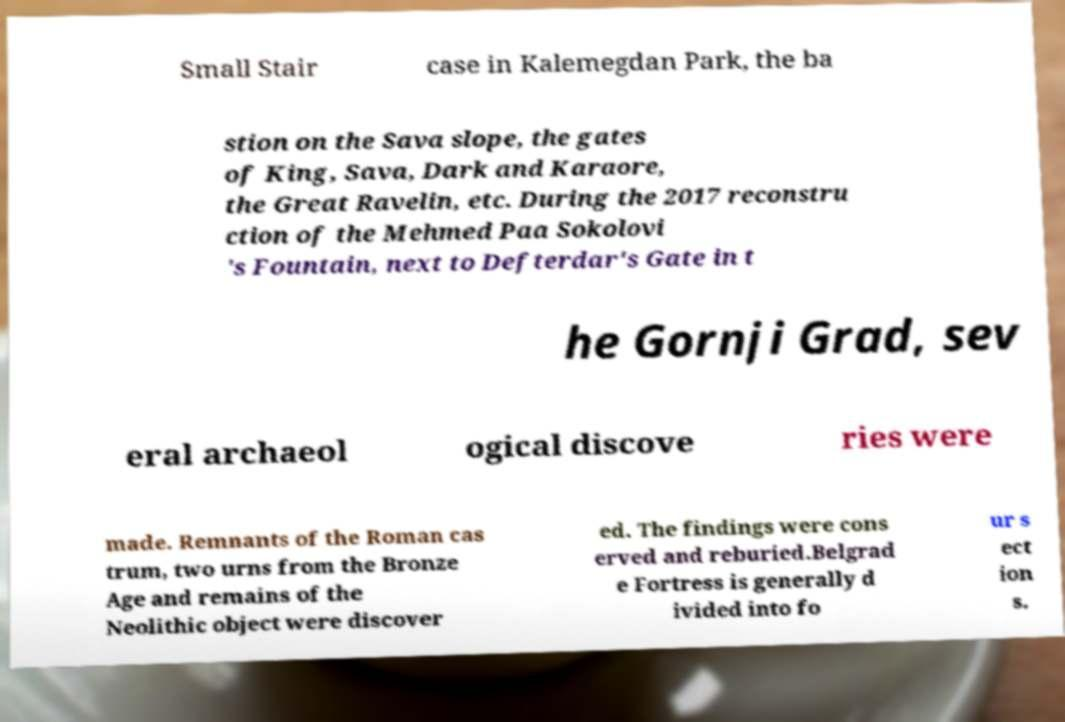Please read and relay the text visible in this image. What does it say? Small Stair case in Kalemegdan Park, the ba stion on the Sava slope, the gates of King, Sava, Dark and Karaore, the Great Ravelin, etc. During the 2017 reconstru ction of the Mehmed Paa Sokolovi 's Fountain, next to Defterdar's Gate in t he Gornji Grad, sev eral archaeol ogical discove ries were made. Remnants of the Roman cas trum, two urns from the Bronze Age and remains of the Neolithic object were discover ed. The findings were cons erved and reburied.Belgrad e Fortress is generally d ivided into fo ur s ect ion s. 